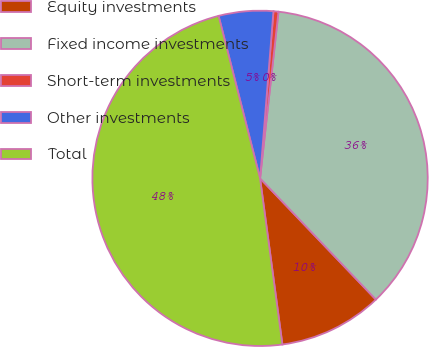Convert chart to OTSL. <chart><loc_0><loc_0><loc_500><loc_500><pie_chart><fcel>Equity investments<fcel>Fixed income investments<fcel>Short-term investments<fcel>Other investments<fcel>Total<nl><fcel>10.01%<fcel>36.11%<fcel>0.48%<fcel>5.25%<fcel>48.15%<nl></chart> 